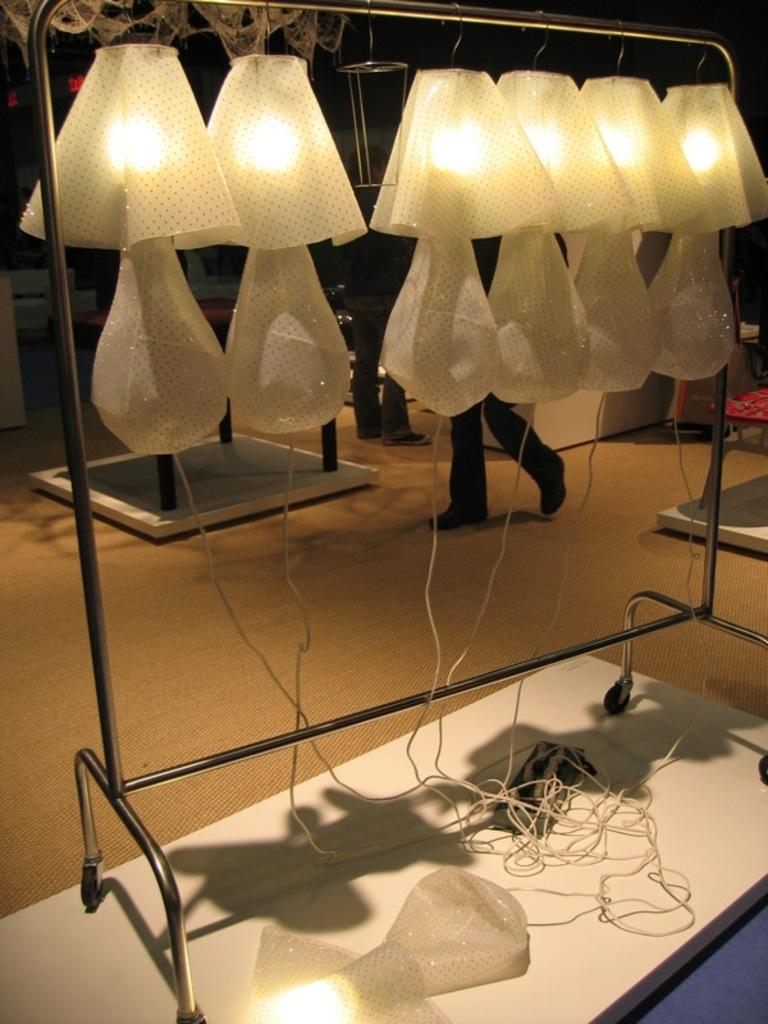What is the main object in the image? There is a switchboard in the image. What is connected to the switchboard? There are wires in the image that are connected to the switchboard. What is the object on the white surface? There is an object on a white surface, but the specific object is not mentioned in the facts. What type of lighting is present in the image? There are lights on a stand in the image. Are there any people visible in the image? Yes, there are two people in the background of the image. What else can be seen in the background of the image? There are other objects in the background of the image, but their specific nature is not mentioned in the facts. What type of guitar is being played by the company in the image? There is no guitar or company present in the image. 